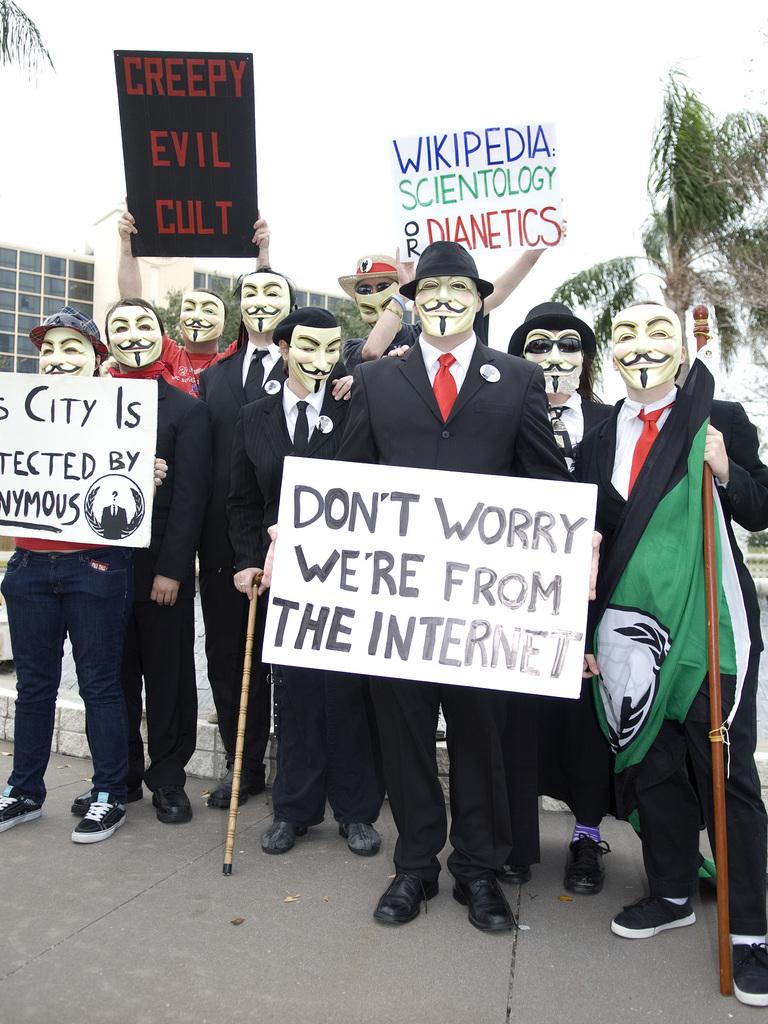Where are these people from?
Your answer should be compact. The internet. 